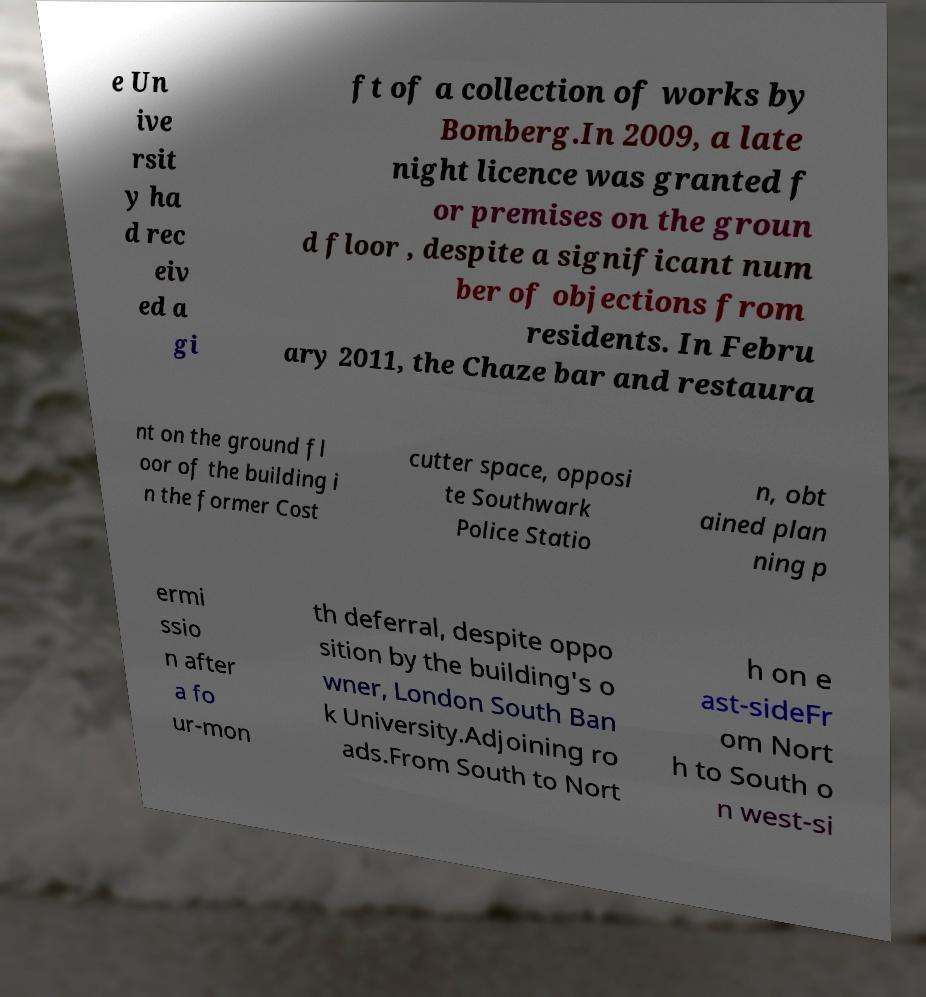Please identify and transcribe the text found in this image. e Un ive rsit y ha d rec eiv ed a gi ft of a collection of works by Bomberg.In 2009, a late night licence was granted f or premises on the groun d floor , despite a significant num ber of objections from residents. In Febru ary 2011, the Chaze bar and restaura nt on the ground fl oor of the building i n the former Cost cutter space, opposi te Southwark Police Statio n, obt ained plan ning p ermi ssio n after a fo ur-mon th deferral, despite oppo sition by the building's o wner, London South Ban k University.Adjoining ro ads.From South to Nort h on e ast-sideFr om Nort h to South o n west-si 